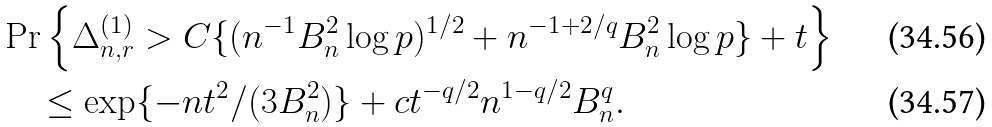Convert formula to latex. <formula><loc_0><loc_0><loc_500><loc_500>& \Pr \left \{ \Delta _ { n , r } ^ { ( 1 ) } > C \{ ( n ^ { - 1 } B _ { n } ^ { 2 } \log p ) ^ { 1 / 2 } + n ^ { - 1 + 2 / q } B _ { n } ^ { 2 } \log p \} + t \right \} \\ & \quad \leq \exp \{ - n t ^ { 2 } / ( 3 B _ { n } ^ { 2 } ) \} + c t ^ { - q / 2 } n ^ { 1 - q / 2 } B _ { n } ^ { q } .</formula> 